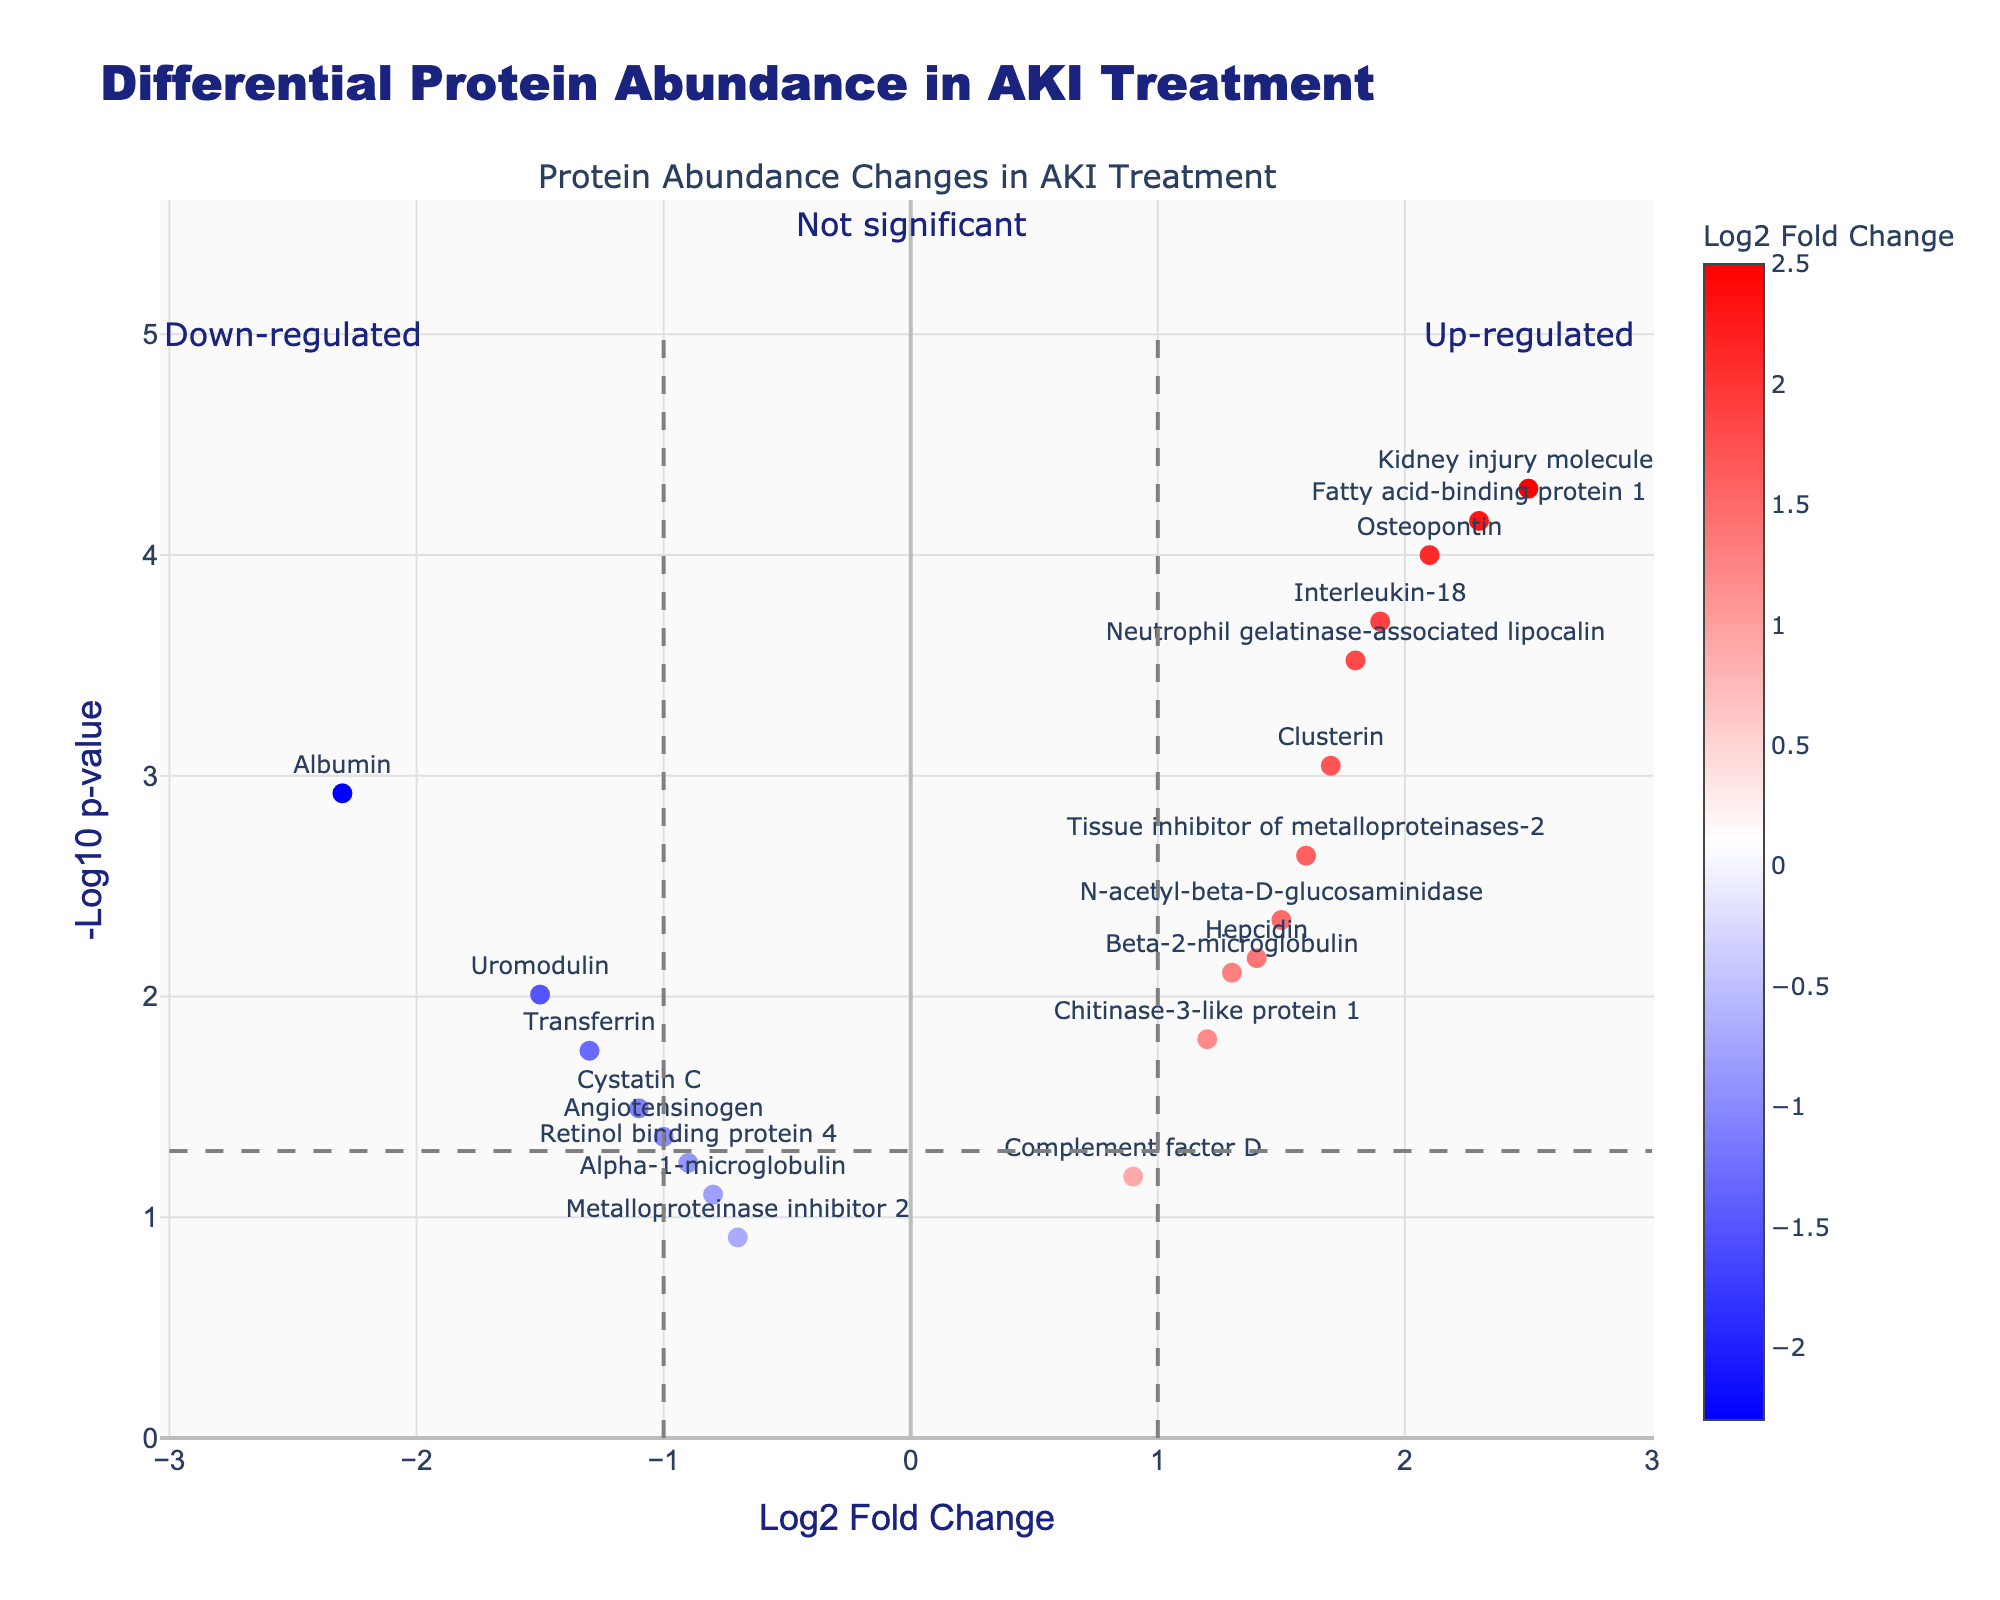What's the title of the plot? The title is displayed at the top of the plot as "Differential Protein Abundance in AKI Treatment".
Answer: Differential Protein Abundance in AKI Treatment How many proteins are down-regulated after treatment? Down-regulated proteins are those with negative log2 fold change (left side of the zero line on the x-axis). Count the markers on the left side to get the total.
Answer: 7 Which protein showed the highest up-regulation after treatment? The highest up-regulated protein will have the maximum positive log2 fold change value. From the data, this corresponds to Kidney injury molecule-1.
Answer: Kidney injury molecule-1 What is the -log10 p-value threshold for statistical significance in this plot? The horizontal dashed line on the plot signifies the significance threshold, which is at 1.3 on the y-axis.
Answer: 1.3 Which proteins are considered statistically significant (above the -log10 p-value threshold)? Statistically significant proteins are above the 1.3 threshold on the y-axis. Look at the markers above this line. The proteins are Albumin, Neutrophil gelatinase-associated lipocalin, Kidney injury molecule-1, Beta-2-microglobulin, Clusterin, Osteopontin, N-acetyl-beta-D-glucosaminidase, Interleukin-18, Fatty acid-binding protein 1, Tissue inhibitor of metalloproteinases-2, Hepcidin, Chitinase-3-like protein 1, Uromodulin, and Transferrin.
Answer: 14 proteins What does the color of the markers represent? The color of the markers represents the log2 fold change of the proteins. The color scale ranges from blue (negative log2FC) to red (positive log2FC).
Answer: Log2 Fold Change How many data points have a -log10 p-value greater than 2? Count the number of markers above the 2.0 line on the y-axis, representing -log10 p-value.
Answer: 6 Between Albumin and Uromodulin, which protein is more down-regulated? Compare the log2 fold changes of Albumin and Uromodulin. Albumin has a log2FC of -2.3, and Uromodulin has -1.5, so Albumin is more down-regulated.
Answer: Albumin What's the log2 fold change of the protein with the highest -log10 p-value? The protein with the highest -log10 p-value from the data is Kidney injury molecule-1, having a log2 fold change of 2.5.
Answer: 2.5 Identify a protein with a -log10 p-value less than 1.3 and down-regulated log2FC. Scan the plot for markers below the 1.3 threshold on the y-axis with a negative log2FC. Retinol binding protein 4 fits these criteria.
Answer: Retinol binding protein 4 